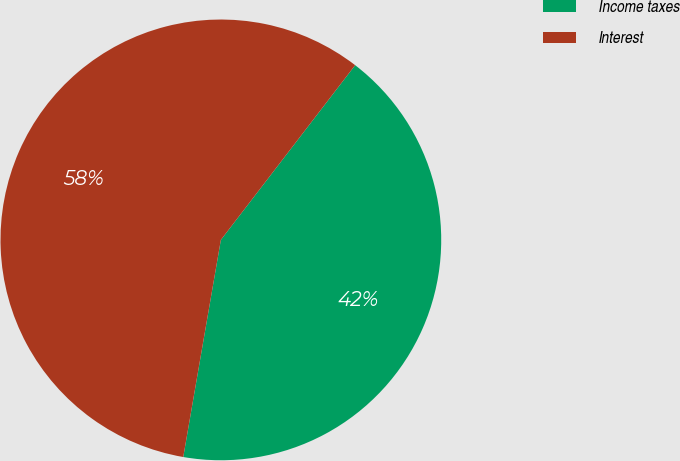Convert chart to OTSL. <chart><loc_0><loc_0><loc_500><loc_500><pie_chart><fcel>Income taxes<fcel>Interest<nl><fcel>42.3%<fcel>57.7%<nl></chart> 